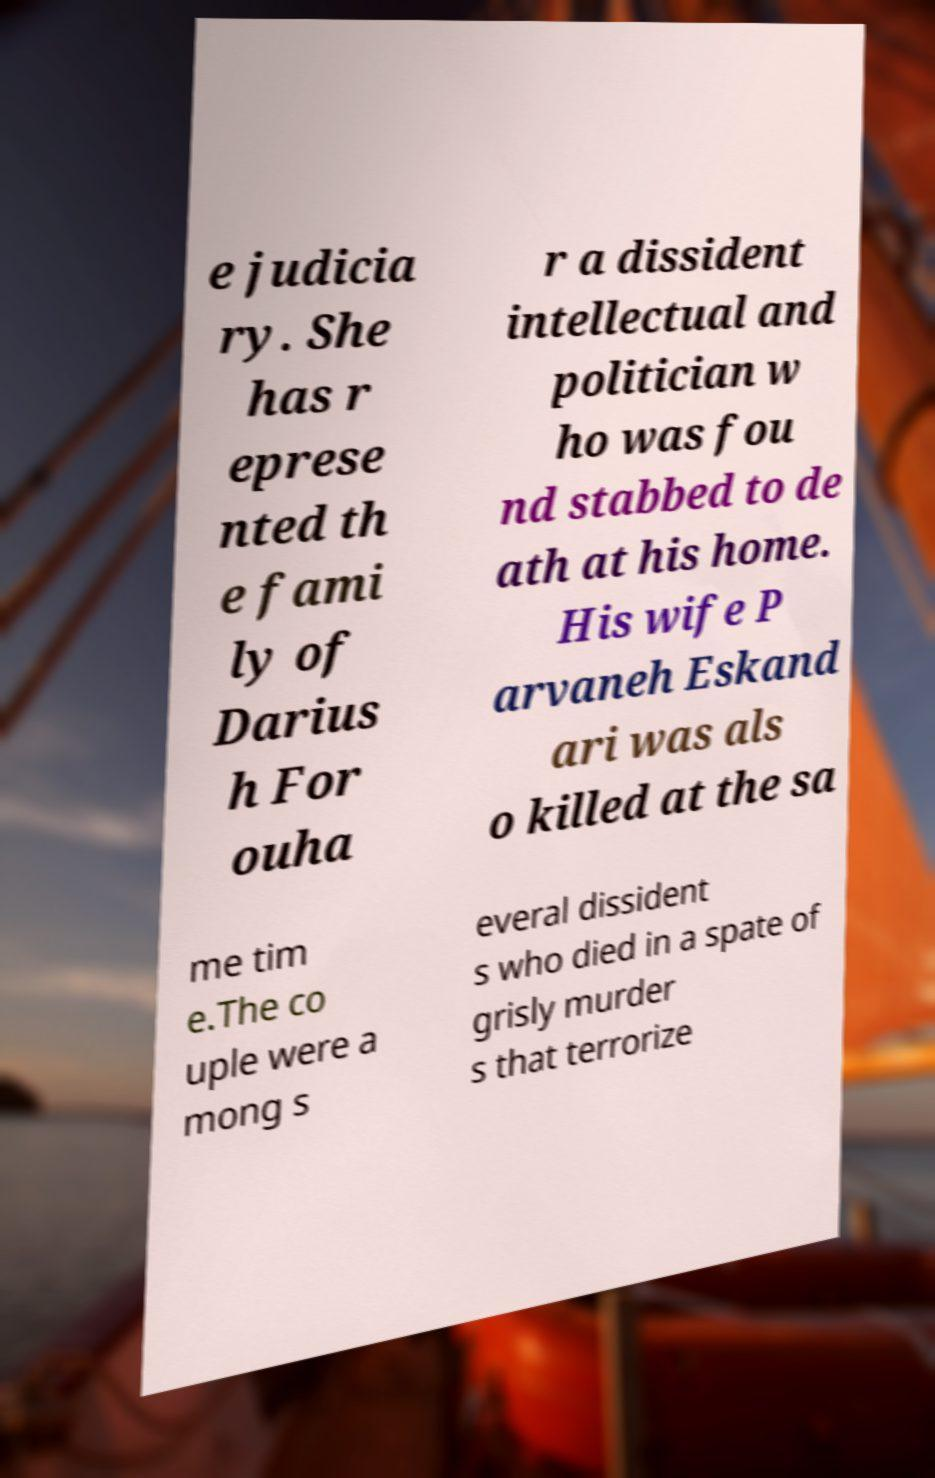Please identify and transcribe the text found in this image. e judicia ry. She has r eprese nted th e fami ly of Darius h For ouha r a dissident intellectual and politician w ho was fou nd stabbed to de ath at his home. His wife P arvaneh Eskand ari was als o killed at the sa me tim e.The co uple were a mong s everal dissident s who died in a spate of grisly murder s that terrorize 